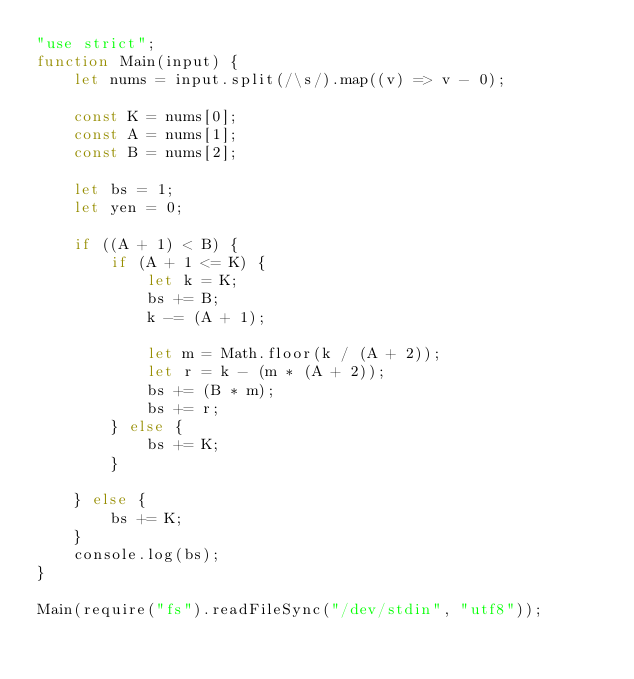Convert code to text. <code><loc_0><loc_0><loc_500><loc_500><_JavaScript_>"use strict";
function Main(input) {
    let nums = input.split(/\s/).map((v) => v - 0);

    const K = nums[0];
    const A = nums[1];
    const B = nums[2];

    let bs = 1;
    let yen = 0;
    
    if ((A + 1) < B) {
        if (A + 1 <= K) {
            let k = K;
            bs += B;
            k -= (A + 1);

            let m = Math.floor(k / (A + 2));
            let r = k - (m * (A + 2));
            bs += (B * m);
            bs += r;
        } else {
            bs += K;
        }

    } else {
        bs += K;
    }
    console.log(bs);
}

Main(require("fs").readFileSync("/dev/stdin", "utf8"));
</code> 